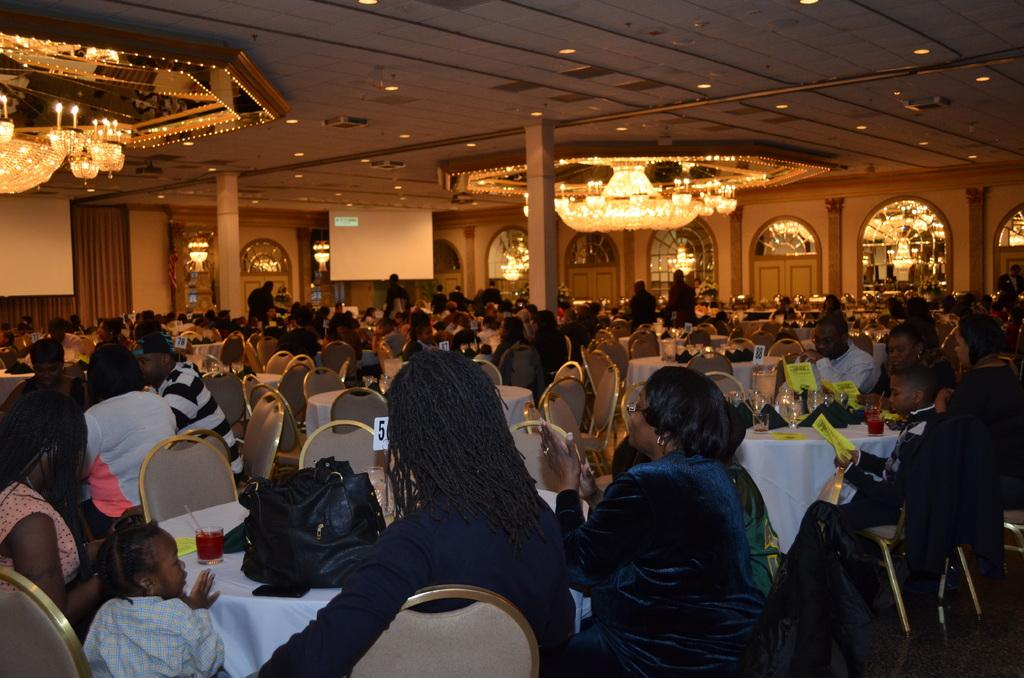What are the people in the image doing? There is a group of people sitting on chairs in the image. What can be seen hanging from the roof in the image? There is a chandelier attached to the roof in the image. What objects are on the table in the image? There is a glass and a bag on a table in the image. What type of skin can be seen on the rat in the image? There is no rat present in the image, so there is no skin to describe. 